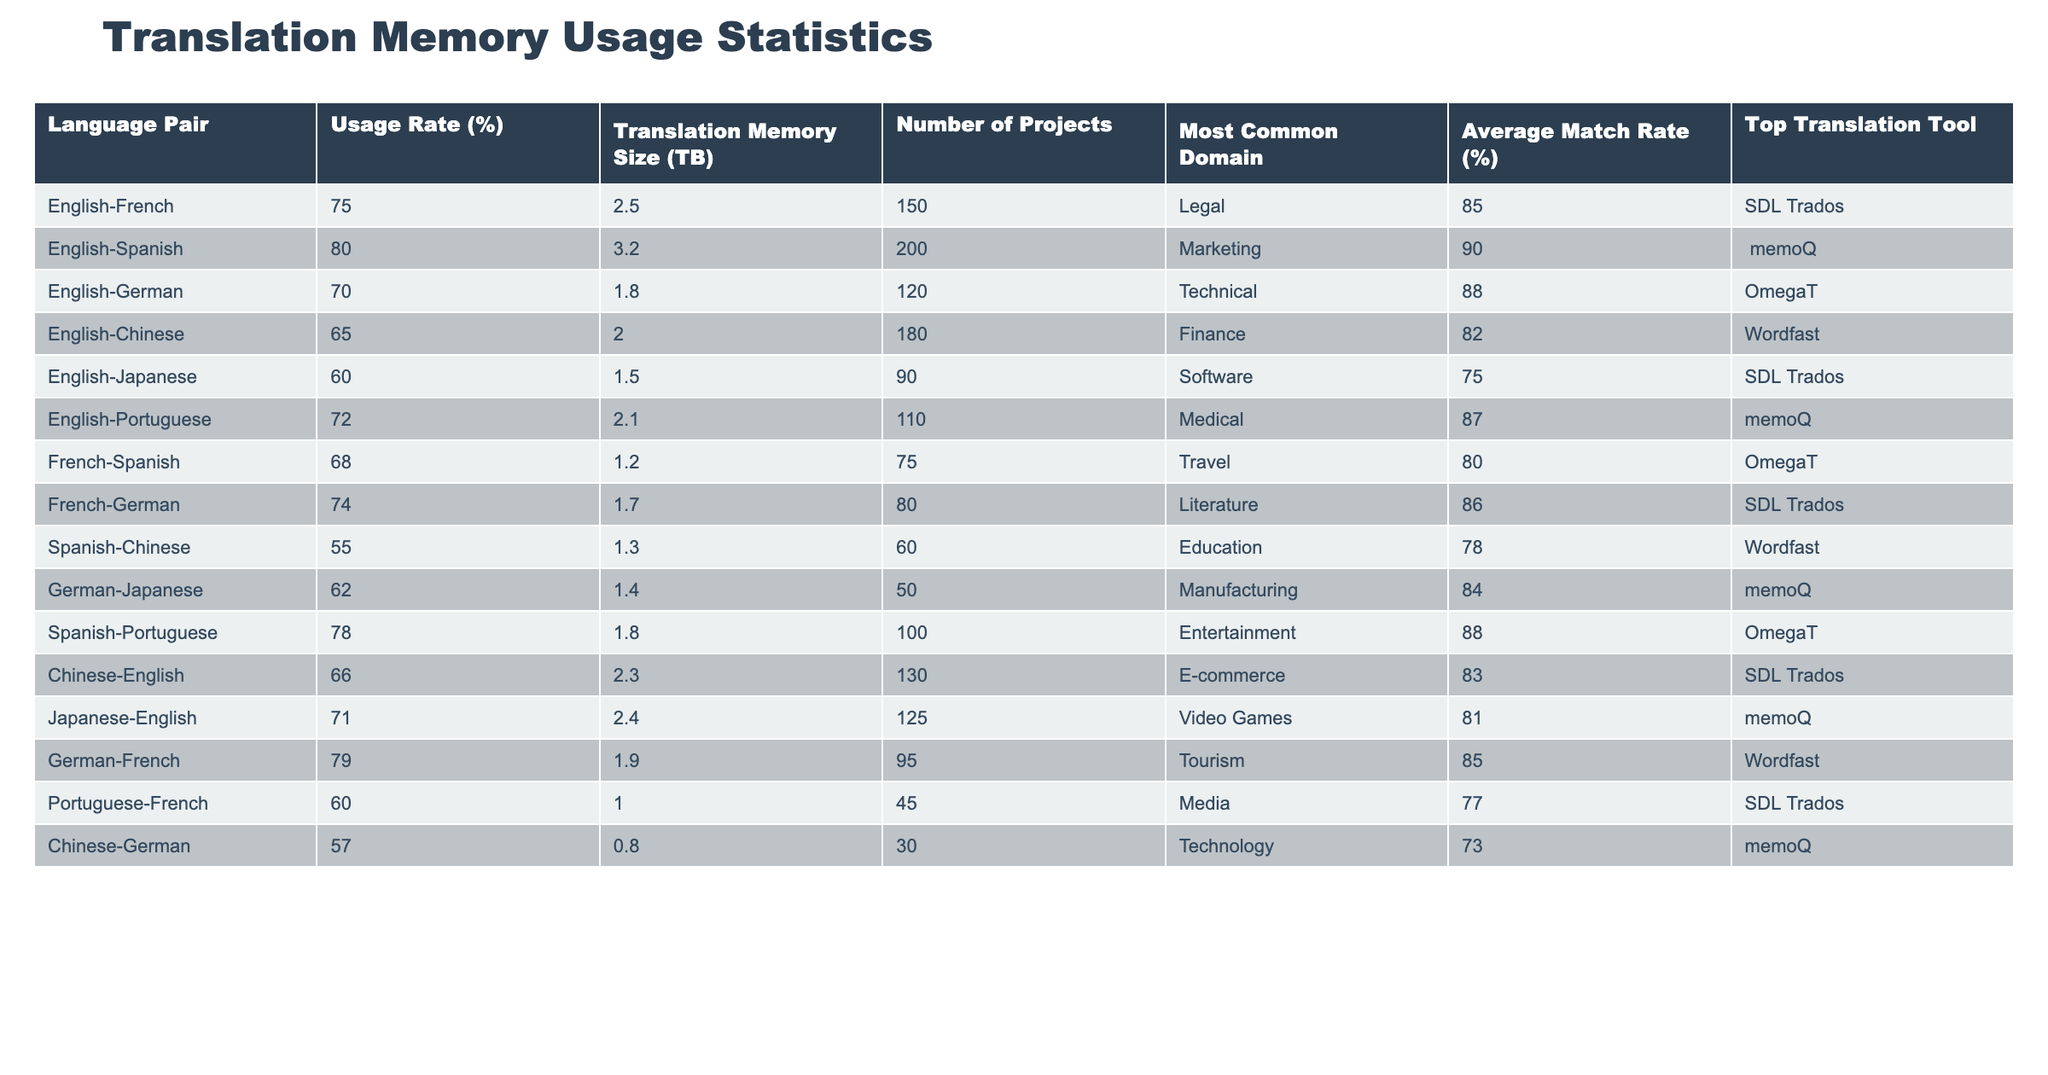What is the usage rate for the English-German language pair? Referring to the table, the usage rate for the English-German language pair is directly listed under the "Usage Rate (%)" column. It shows a value of 70%.
Answer: 70% What is the most common domain for the Spanish-Portuguese language pair? The most common domain can be found in the "Most Common Domain" column of the Spanish-Portuguese row, which indicates "Entertainment."
Answer: Entertainment What is the average match rate for all language pairs listed in the table? First, sum the average match rates for all language pairs: (85 + 90 + 88 + 82 + 75 + 87 + 80 + 86 + 78 + 84 + 88 + 83 + 81 + 85 + 77 + 73) = 1303. Since there are 16 language pairs, the average match rate is 1303 / 16 ≈ 81.44%.
Answer: 81.44% Which language pair has the largest translation memory size? By looking through the "Translation Memory Size (TB)" column, the largest value is 3.2 TB, which corresponds to the English-Spanish language pair.
Answer: English-Spanish Do any language pairs have an average match rate lower than 70%? By reviewing the "Average Match Rate (%)" column, the language pairs with values below 70% are English-Japanese (75%) and Spanish-Chinese (78%), so it is true that some language pairs have an average match rate lower than 70%.
Answer: Yes What is the difference in translation memory size between the English-French and English-Italian language pairs? There is no English-Italian language pair listed in the table; therefore, we only compare the translation memory size of English-French, which is 2.5 TB, and cannot make a comparison. Hence, the question reflects that there isn't a counterpart for comparison.
Answer: Not applicable Which language pair with a higher usage rate also has German as a part? The English-German pair has a usage rate of 70%, but the German-French pair has a usage rate of 79%. Since German is present in both, the one with a higher usage rate is the German-French pair.
Answer: German-French How many projects are substantially more for English-Spanish than for Chinese-German? The number of projects for English-Spanish is 200, and for Chinese-German, it is 30. The difference is calculated as 200 - 30 = 170 projects.
Answer: 170 Which language pair has the lowest average match rate, and what is it? Scanning through the "Average Match Rate (%)" column, the lowest is found under Spanish-Chinese, which has an average match rate of 78%.
Answer: Spanish-Chinese, 78% Is the Translation Memory size for the Portuguese-French language pair over 1 TB? The value for the Portuguese-French language pair is 1.0 TB, so it is not greater than 1 TB. This confirms that the statement is false.
Answer: No How does the usage rate for the English-Portuguese language pair compare to that of the English-Japanese language pair? The English-Portuguese language pair has a usage rate of 72%, while the English-Japanese pair has a rate of 60%. Therefore, the English-Portuguese rate is higher than that of English-Japanese.
Answer: English-Portuguese is higher 